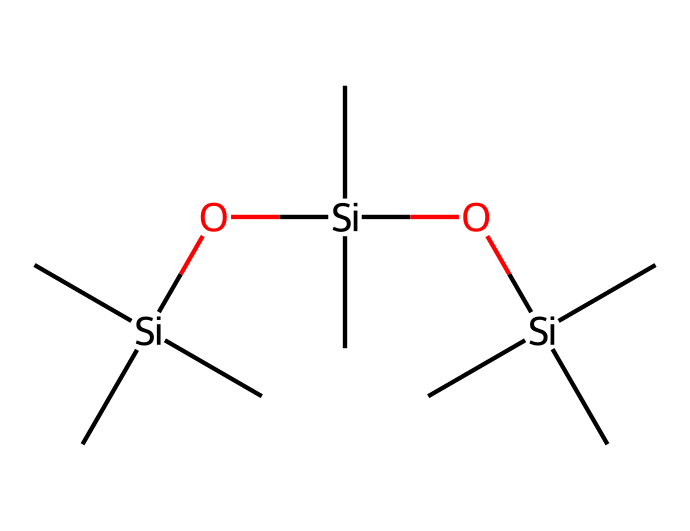What is the molecular formula represented by the SMILES? The SMILES indicates a structure with three silicon atoms and terpenes, so we can summarize it by counting carbon and oxygen atoms as well. It translates to C9H30O3Si3.
Answer: C9H30O3Si3 How many silicon atoms are present in this compound? By examining the SMILES representation, silicon is represented by 'Si', and there are three instances of 'Si' in the structure.
Answer: three What type of compounds does this chemical represent? The presence of silicon (Si) combined with carbon (C) indicates it is an organosilicon compound.
Answer: organosilicon How many ethyl groups are attached to each silicon atom? In the given SMILES, each 'C' before and after silicon indicates ethyl (or methyl) groups, and since each 'Si' connects to three 'C's that means three ethyl groups are around each silicon atom.
Answer: three What functional group is present in this compound? The 'O' atoms in between the silicon atoms suggest the existence of siloxane (Si-O-Si).
Answer: siloxane What is the total number of oxygen atoms in this structure? There are three instances of 'O' in the SMILES representation, indicating the total number of oxygen atoms present in the compound.
Answer: three 